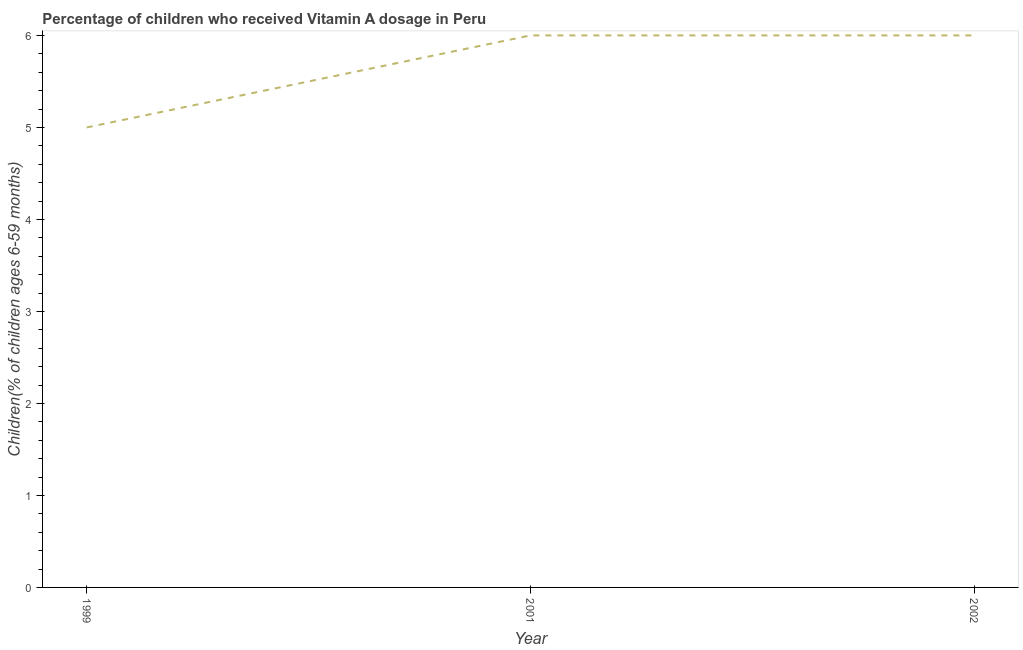What is the vitamin a supplementation coverage rate in 1999?
Provide a short and direct response. 5. Across all years, what is the maximum vitamin a supplementation coverage rate?
Provide a short and direct response. 6. Across all years, what is the minimum vitamin a supplementation coverage rate?
Your answer should be very brief. 5. In which year was the vitamin a supplementation coverage rate maximum?
Ensure brevity in your answer.  2001. What is the sum of the vitamin a supplementation coverage rate?
Keep it short and to the point. 17. What is the average vitamin a supplementation coverage rate per year?
Offer a terse response. 5.67. In how many years, is the vitamin a supplementation coverage rate greater than 3.2 %?
Provide a succinct answer. 3. Do a majority of the years between 1999 and 2002 (inclusive) have vitamin a supplementation coverage rate greater than 4 %?
Offer a very short reply. Yes. Is the difference between the vitamin a supplementation coverage rate in 2001 and 2002 greater than the difference between any two years?
Your response must be concise. No. Is the sum of the vitamin a supplementation coverage rate in 1999 and 2002 greater than the maximum vitamin a supplementation coverage rate across all years?
Make the answer very short. Yes. What is the difference between the highest and the lowest vitamin a supplementation coverage rate?
Your response must be concise. 1. In how many years, is the vitamin a supplementation coverage rate greater than the average vitamin a supplementation coverage rate taken over all years?
Your response must be concise. 2. How many years are there in the graph?
Make the answer very short. 3. Does the graph contain any zero values?
Give a very brief answer. No. What is the title of the graph?
Keep it short and to the point. Percentage of children who received Vitamin A dosage in Peru. What is the label or title of the Y-axis?
Provide a short and direct response. Children(% of children ages 6-59 months). What is the Children(% of children ages 6-59 months) in 2001?
Provide a short and direct response. 6. What is the Children(% of children ages 6-59 months) in 2002?
Your answer should be very brief. 6. What is the difference between the Children(% of children ages 6-59 months) in 1999 and 2002?
Make the answer very short. -1. What is the difference between the Children(% of children ages 6-59 months) in 2001 and 2002?
Your answer should be very brief. 0. What is the ratio of the Children(% of children ages 6-59 months) in 1999 to that in 2001?
Offer a terse response. 0.83. What is the ratio of the Children(% of children ages 6-59 months) in 1999 to that in 2002?
Offer a terse response. 0.83. What is the ratio of the Children(% of children ages 6-59 months) in 2001 to that in 2002?
Give a very brief answer. 1. 